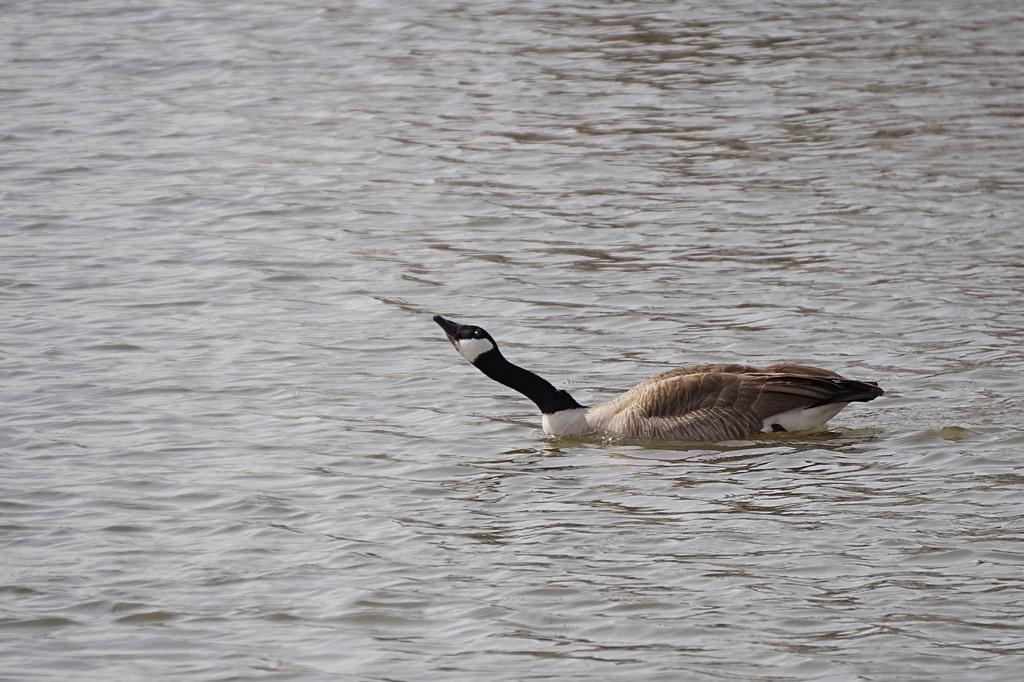What animal is present in the image? There is a duck in the image. Where is the duck located? The duck is in the water. What is the condition of the water in the image? The water is flowing. What type of coal can be seen in the image? There is no coal present in the image; it features a duck in flowing water. How many books are visible in the image? There are no books present in the image. 